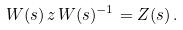<formula> <loc_0><loc_0><loc_500><loc_500>W ( s ) \, z \, W ( s ) ^ { - 1 } = Z ( s ) \, .</formula> 